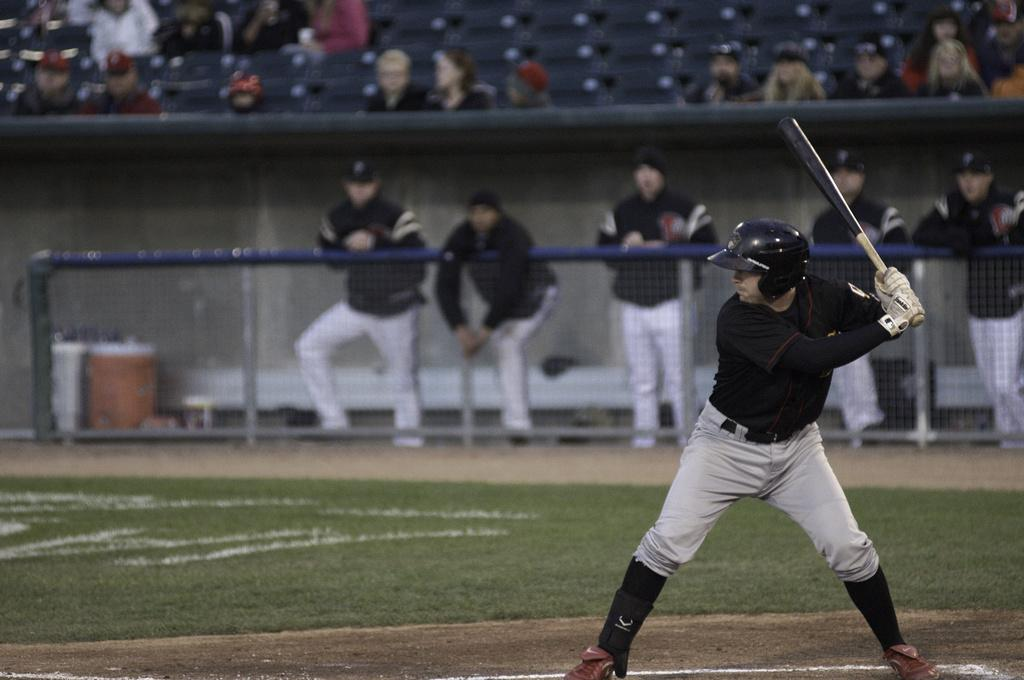Where was the image taken? The image was taken in a stadium. What is the person in the image doing? The person is holding a baseball bat and is ready to give his shot. What can be seen in the background of the image? There are spectators in the image. What type of basket is the person holding in the image? There is no basket present in the image; the person is holding a baseball bat. What substance is being used to tie the string in the image? There is no string or substance mentioned in the image; it features a person holding a baseball bat in a stadium with spectators. 